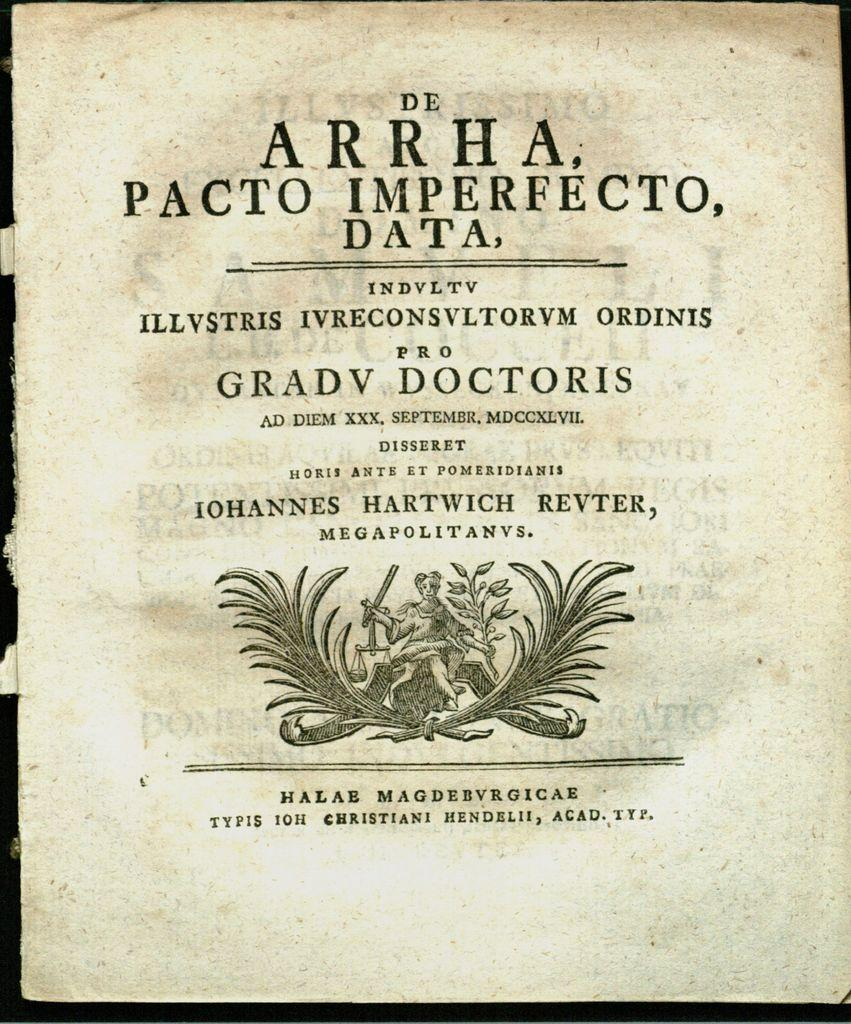What is present in the image that contains information? There is a paper in the image that contains words. What else can be seen on the paper? The paper has a logo on it. How many cherries are hanging from the lace in the image? There are no cherries or lace present in the image. 